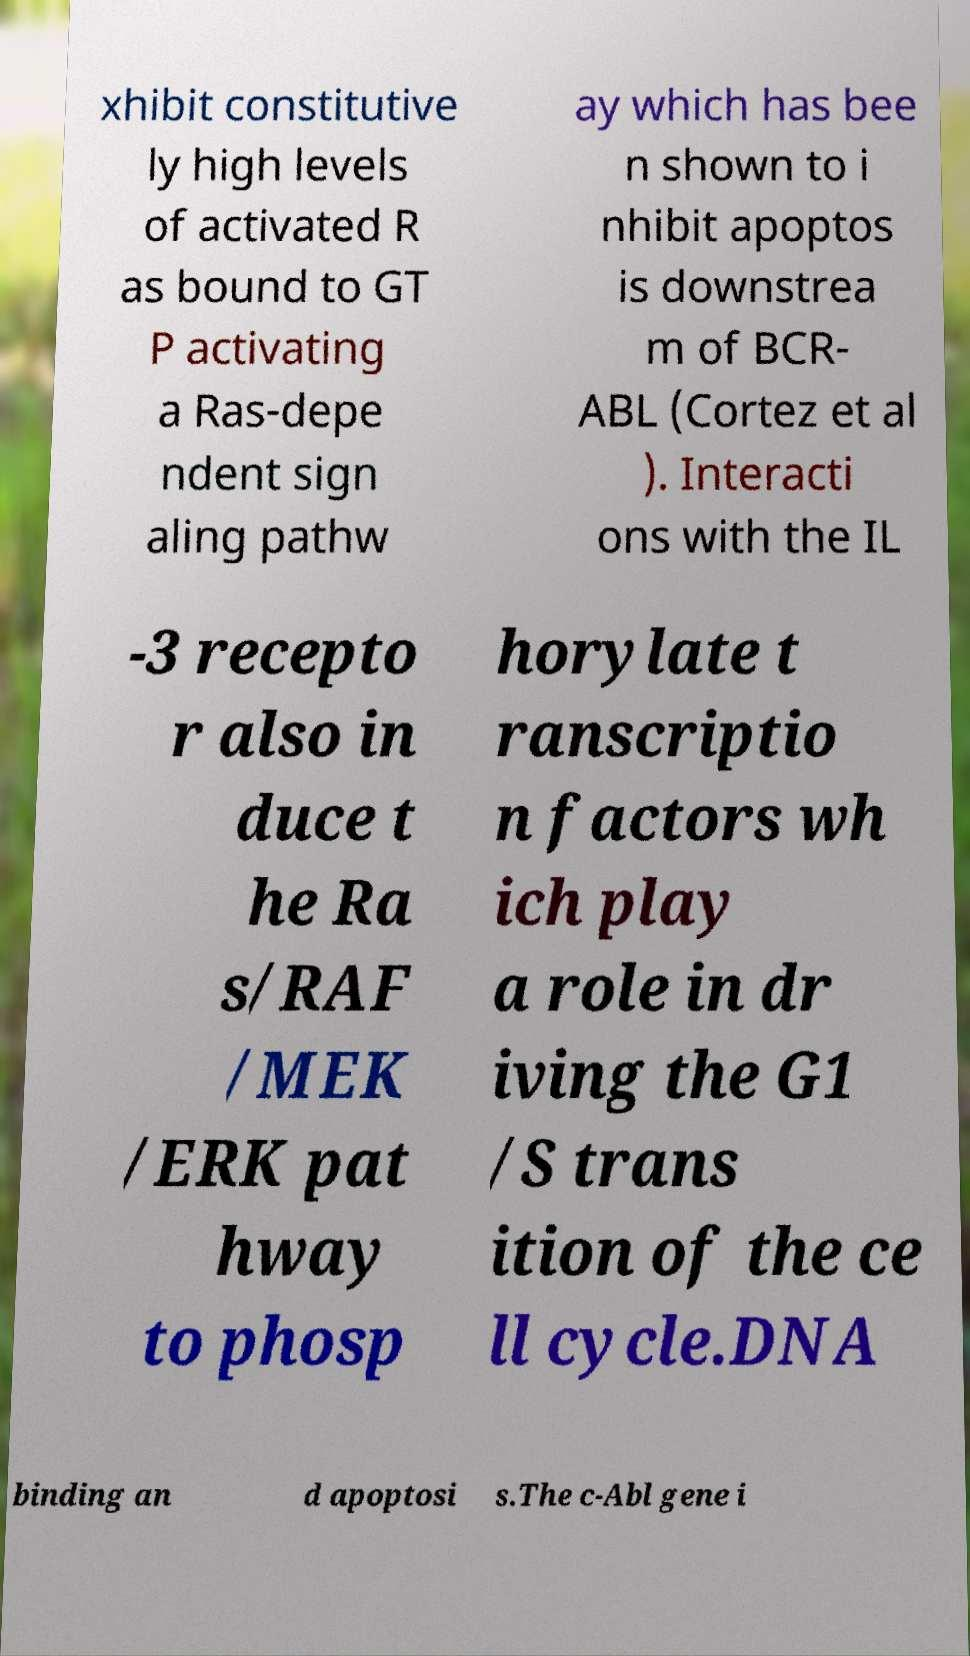Can you accurately transcribe the text from the provided image for me? xhibit constitutive ly high levels of activated R as bound to GT P activating a Ras-depe ndent sign aling pathw ay which has bee n shown to i nhibit apoptos is downstrea m of BCR- ABL (Cortez et al ). Interacti ons with the IL -3 recepto r also in duce t he Ra s/RAF /MEK /ERK pat hway to phosp horylate t ranscriptio n factors wh ich play a role in dr iving the G1 /S trans ition of the ce ll cycle.DNA binding an d apoptosi s.The c-Abl gene i 